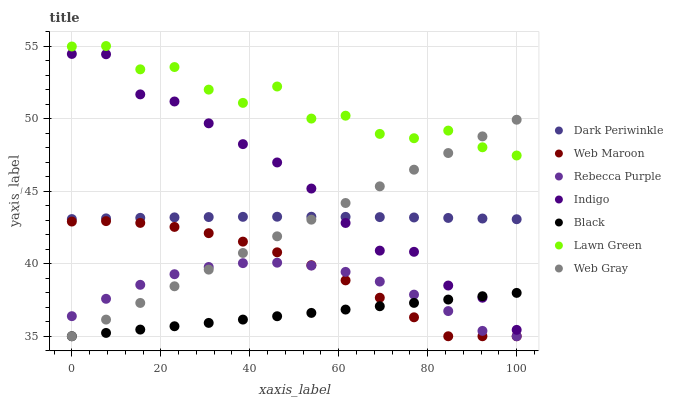Does Black have the minimum area under the curve?
Answer yes or no. Yes. Does Lawn Green have the maximum area under the curve?
Answer yes or no. Yes. Does Web Gray have the minimum area under the curve?
Answer yes or no. No. Does Web Gray have the maximum area under the curve?
Answer yes or no. No. Is Black the smoothest?
Answer yes or no. Yes. Is Lawn Green the roughest?
Answer yes or no. Yes. Is Web Gray the smoothest?
Answer yes or no. No. Is Web Gray the roughest?
Answer yes or no. No. Does Web Gray have the lowest value?
Answer yes or no. Yes. Does Indigo have the lowest value?
Answer yes or no. No. Does Lawn Green have the highest value?
Answer yes or no. Yes. Does Web Gray have the highest value?
Answer yes or no. No. Is Black less than Lawn Green?
Answer yes or no. Yes. Is Dark Periwinkle greater than Black?
Answer yes or no. Yes. Does Web Gray intersect Indigo?
Answer yes or no. Yes. Is Web Gray less than Indigo?
Answer yes or no. No. Is Web Gray greater than Indigo?
Answer yes or no. No. Does Black intersect Lawn Green?
Answer yes or no. No. 